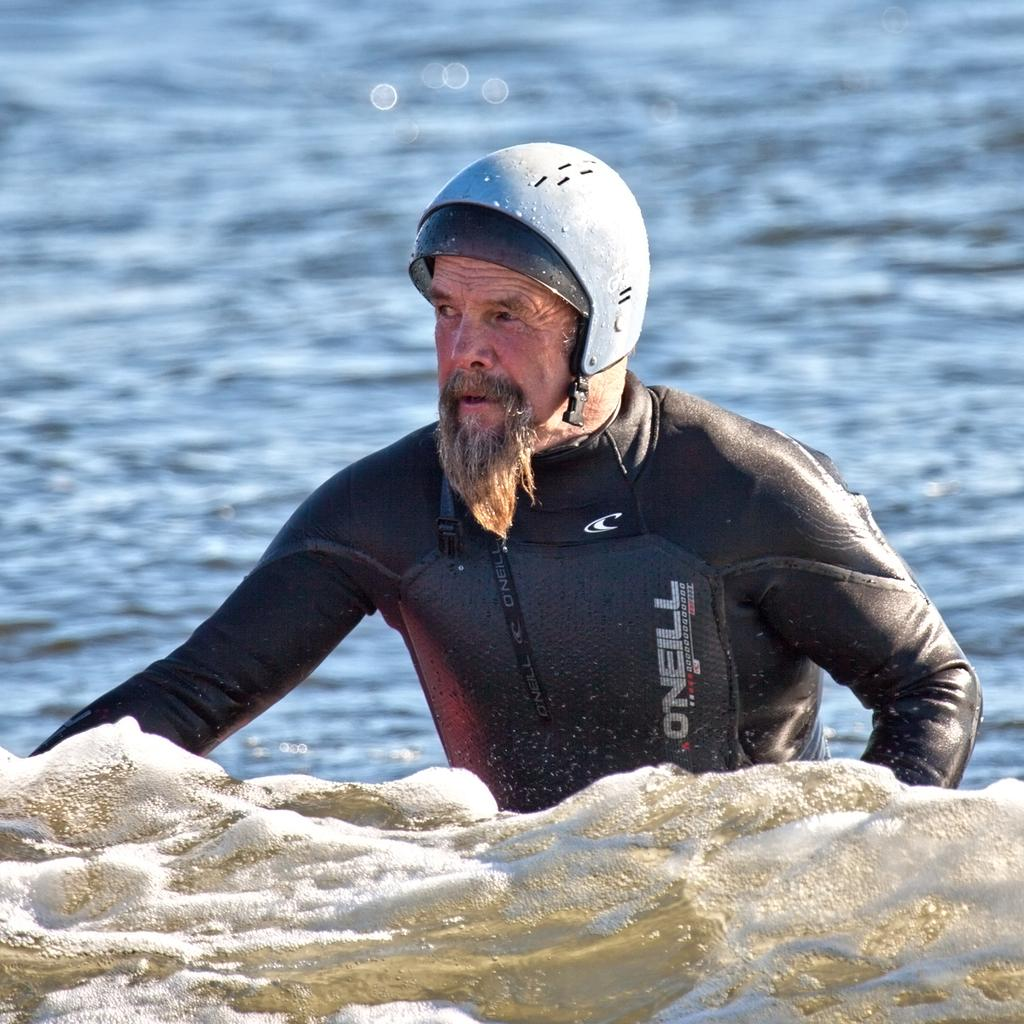What is present in the image that is not a person or object? There is water in the image. Can you describe the man in the image? The man in the image is wearing a wetsuit and a helmet. What type of vegetable is being used as a pail by the kittens in the image? There are no kittens or vegetables present in the image. 